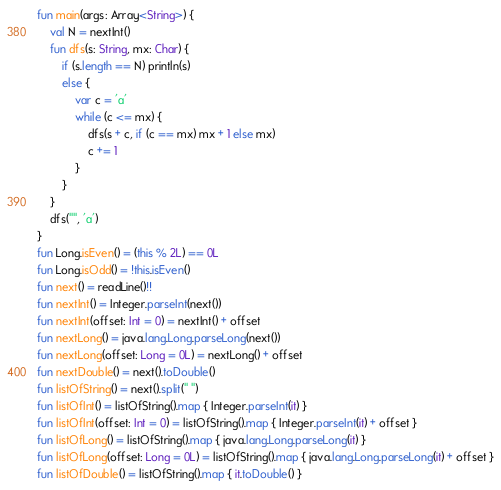<code> <loc_0><loc_0><loc_500><loc_500><_Kotlin_>fun main(args: Array<String>) {
    val N = nextInt()
    fun dfs(s: String, mx: Char) {
        if (s.length == N) println(s)
        else {
            var c = 'a'
            while (c <= mx) {
                dfs(s + c, if (c == mx) mx + 1 else mx)
                c += 1
            }
        }
    }
    dfs("", 'a')
}
fun Long.isEven() = (this % 2L) == 0L
fun Long.isOdd() = !this.isEven()
fun next() = readLine()!!
fun nextInt() = Integer.parseInt(next())
fun nextInt(offset: Int = 0) = nextInt() + offset
fun nextLong() = java.lang.Long.parseLong(next())
fun nextLong(offset: Long = 0L) = nextLong() + offset
fun nextDouble() = next().toDouble()
fun listOfString() = next().split(" ")
fun listOfInt() = listOfString().map { Integer.parseInt(it) }
fun listOfInt(offset: Int = 0) = listOfString().map { Integer.parseInt(it) + offset }
fun listOfLong() = listOfString().map { java.lang.Long.parseLong(it) }
fun listOfLong(offset: Long = 0L) = listOfString().map { java.lang.Long.parseLong(it) + offset }
fun listOfDouble() = listOfString().map { it.toDouble() }
</code> 